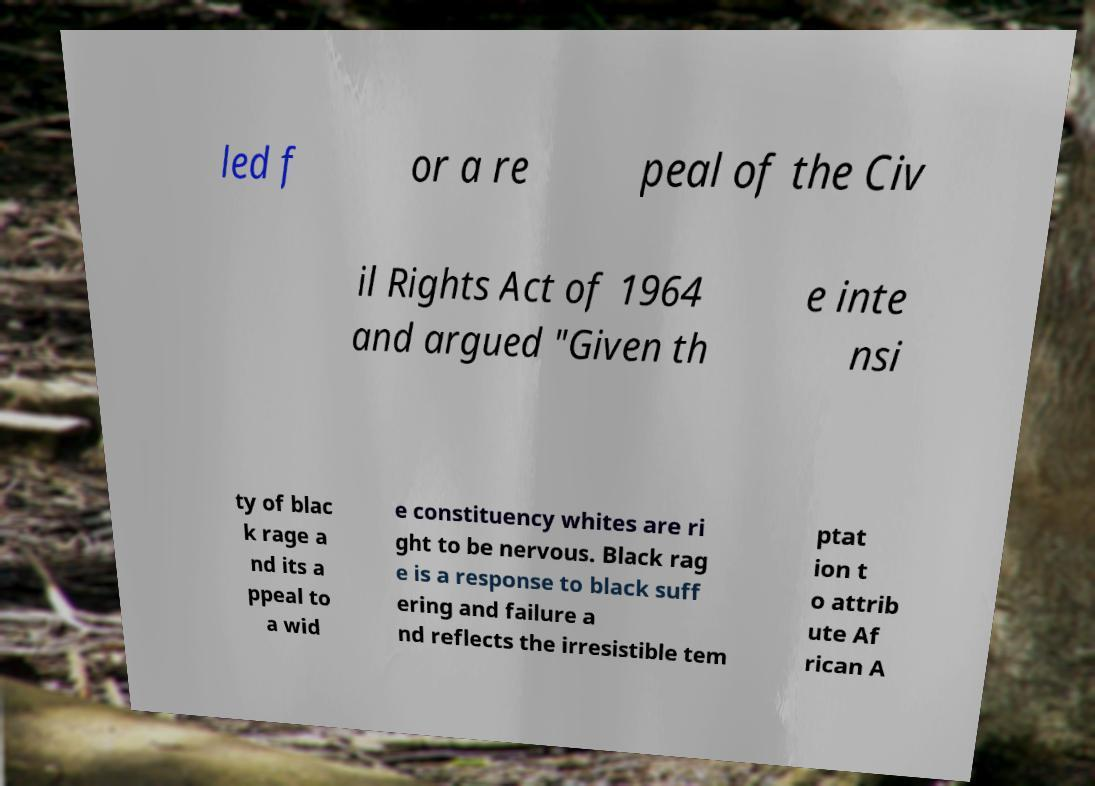Can you read and provide the text displayed in the image?This photo seems to have some interesting text. Can you extract and type it out for me? led f or a re peal of the Civ il Rights Act of 1964 and argued "Given th e inte nsi ty of blac k rage a nd its a ppeal to a wid e constituency whites are ri ght to be nervous. Black rag e is a response to black suff ering and failure a nd reflects the irresistible tem ptat ion t o attrib ute Af rican A 